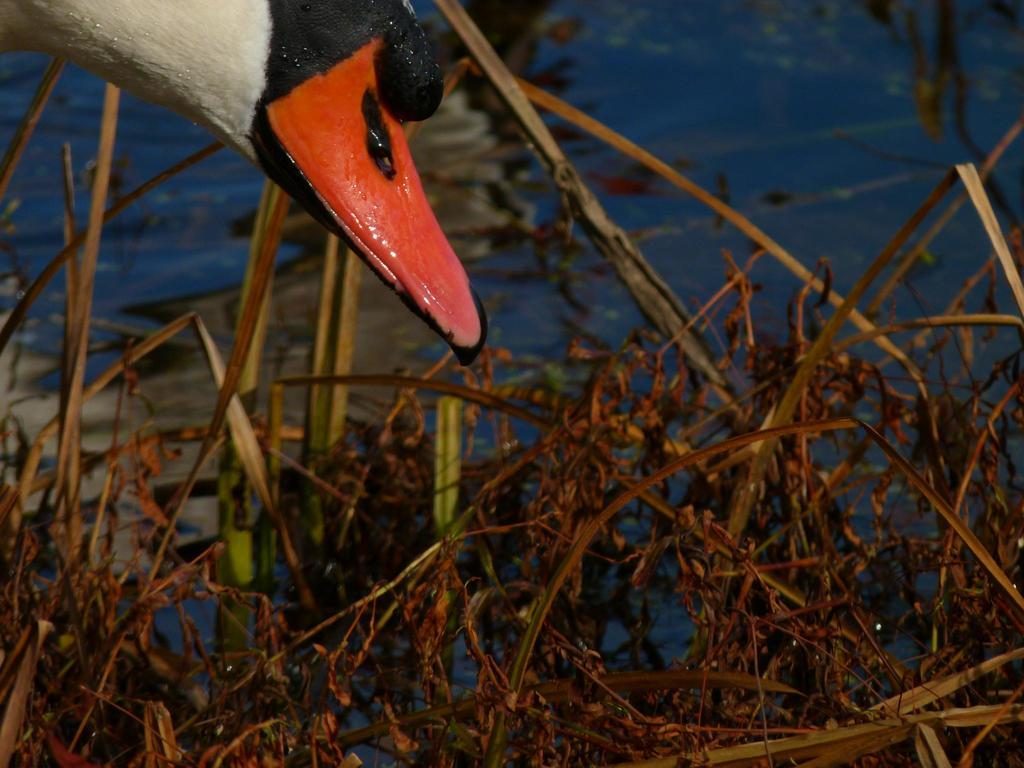What type of animal is present in the image? There is a bird in the image. What is a distinctive feature of the bird? The bird has a beak. What type of vegetation is present in the image? There are dried plants in the image. What is the other main element in the image besides the bird and dried plants? There is a water surface in the image. What color is the desk in the image? There is no desk present in the image. 